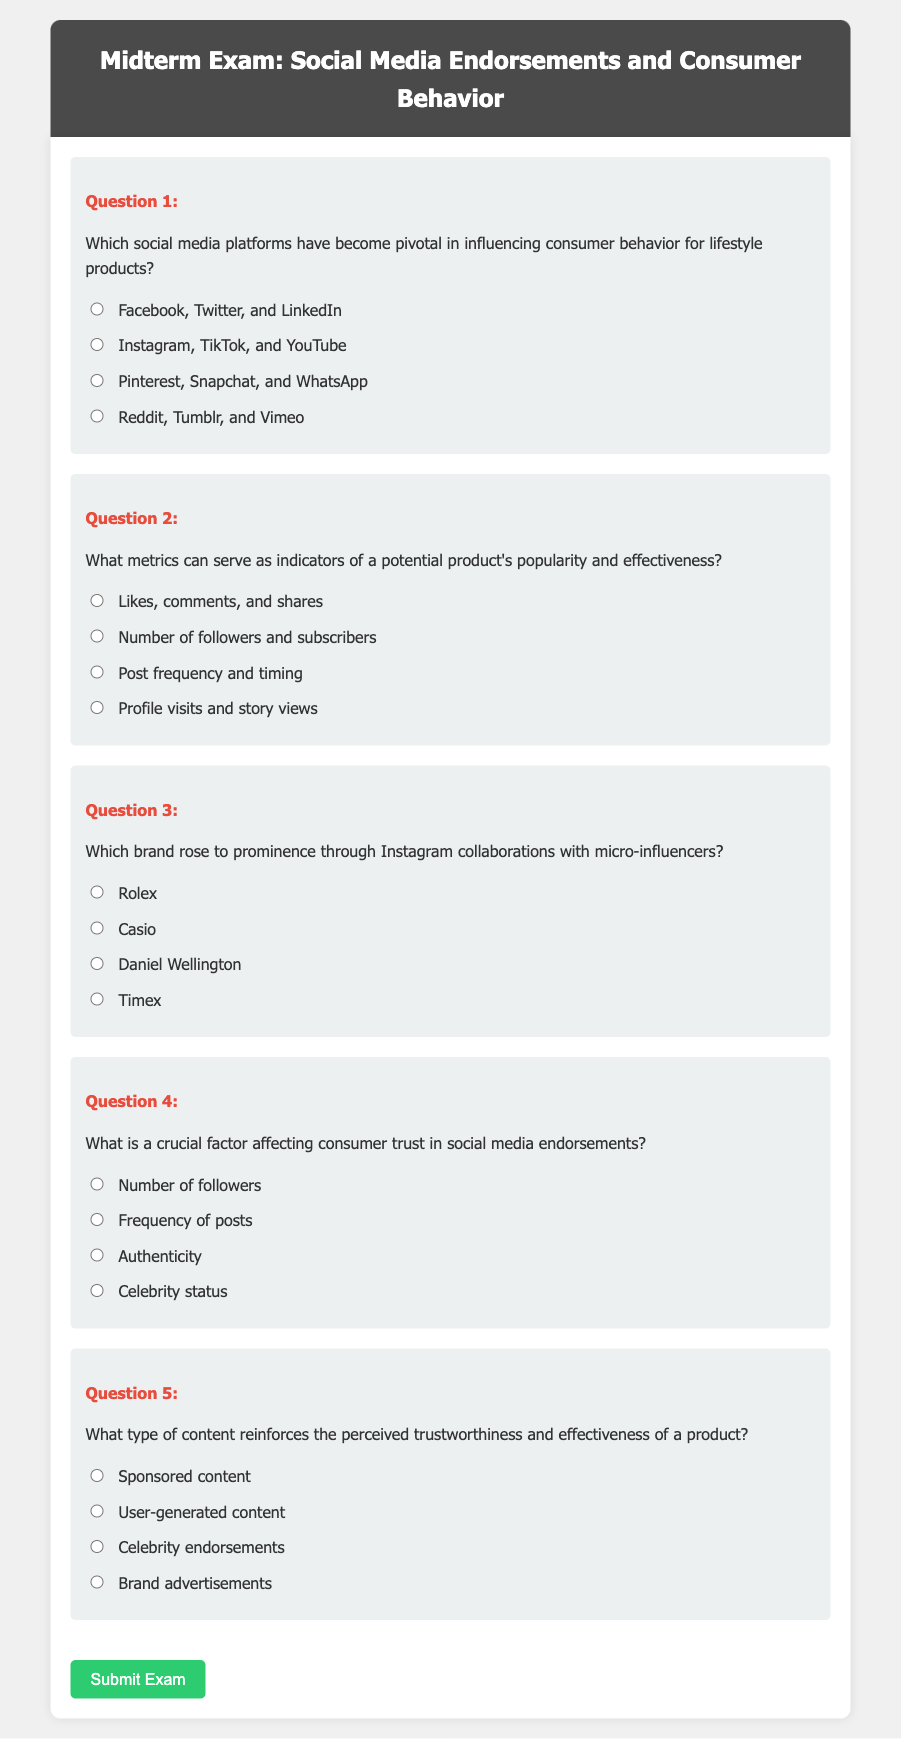What is the title of the document? The title appears in the header section of the document and is "Midterm Exam: Social Media Endorsements and Consumer Behavior."
Answer: Midterm Exam: Social Media Endorsements and Consumer Behavior Which social media platforms are mentioned as pivotal for influencing consumer behavior? The options provided in Question 1 highlight Instagram, TikTok, and YouTube as key platforms for lifestyle product influence.
Answer: Instagram, TikTok, and YouTube What type of content is mentioned in Question 5 that reinforces trustworthiness? The options listed include user-generated content, which is noted as effective for reinforcing perceived trustworthiness of a product.
Answer: User-generated content What is the crucial factor affecting consumer trust as per Question 4? The question highlights "authenticity" as a crucial factor influencing consumer trust in social media endorsements.
Answer: Authenticity Which brand is associated with Instagram collaborations in Question 3? The question identifies Daniel Wellington as the brand known for rising to prominence through Instagram collaborations.
Answer: Daniel Wellington 